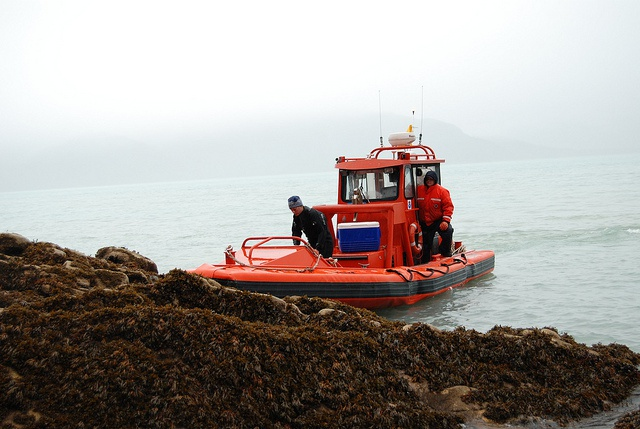Describe the objects in this image and their specific colors. I can see boat in white, black, brown, lightgray, and maroon tones, people in white, black, maroon, and red tones, and people in white, black, gray, maroon, and darkgray tones in this image. 